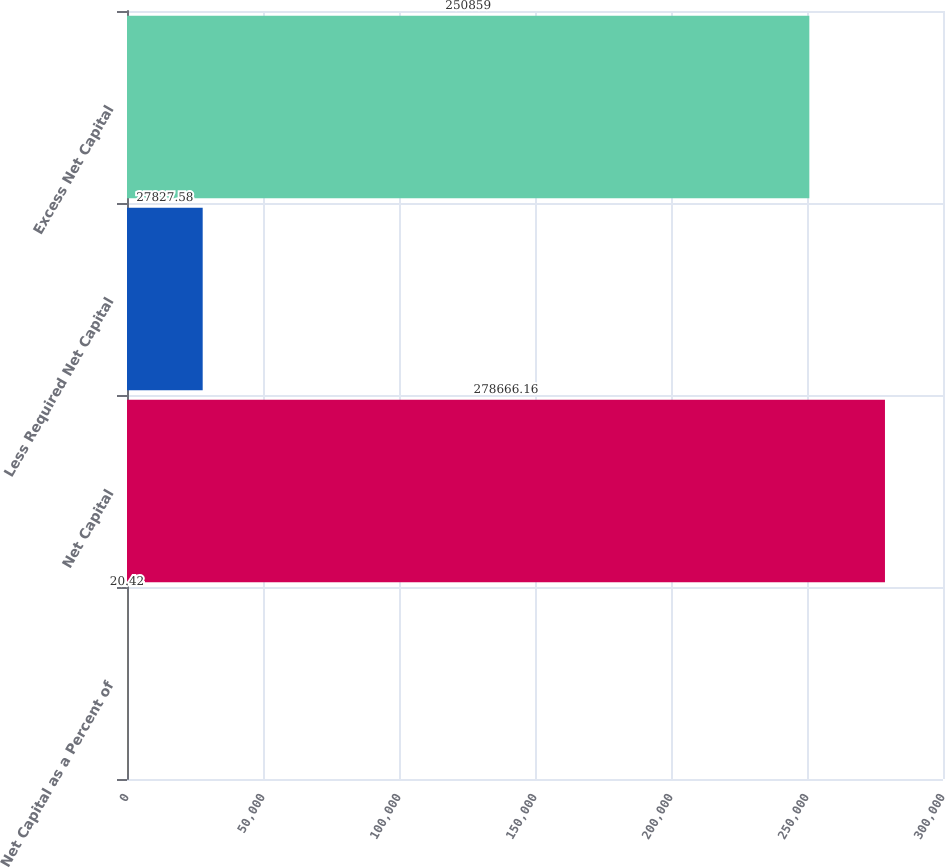Convert chart. <chart><loc_0><loc_0><loc_500><loc_500><bar_chart><fcel>Net Capital as a Percent of<fcel>Net Capital<fcel>Less Required Net Capital<fcel>Excess Net Capital<nl><fcel>20.42<fcel>278666<fcel>27827.6<fcel>250859<nl></chart> 